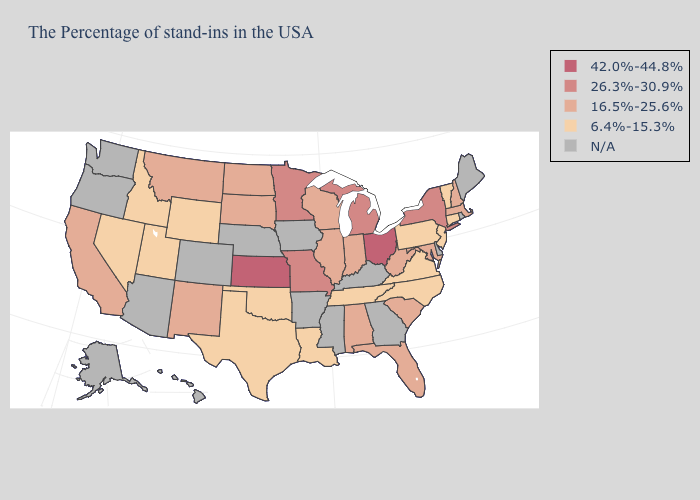Does the map have missing data?
Quick response, please. Yes. Name the states that have a value in the range 16.5%-25.6%?
Keep it brief. Massachusetts, New Hampshire, Maryland, South Carolina, West Virginia, Florida, Indiana, Alabama, Wisconsin, Illinois, South Dakota, North Dakota, New Mexico, Montana, California. What is the value of Texas?
Keep it brief. 6.4%-15.3%. Does Tennessee have the lowest value in the USA?
Be succinct. Yes. Name the states that have a value in the range 26.3%-30.9%?
Answer briefly. New York, Michigan, Missouri, Minnesota. What is the value of Kansas?
Short answer required. 42.0%-44.8%. What is the value of Minnesota?
Give a very brief answer. 26.3%-30.9%. What is the value of Rhode Island?
Concise answer only. N/A. Name the states that have a value in the range 42.0%-44.8%?
Short answer required. Ohio, Kansas. What is the value of South Dakota?
Be succinct. 16.5%-25.6%. What is the highest value in the USA?
Answer briefly. 42.0%-44.8%. What is the value of Arkansas?
Short answer required. N/A. Name the states that have a value in the range 26.3%-30.9%?
Concise answer only. New York, Michigan, Missouri, Minnesota. 